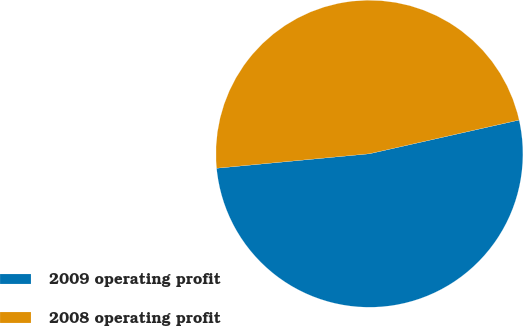Convert chart to OTSL. <chart><loc_0><loc_0><loc_500><loc_500><pie_chart><fcel>2009 operating profit<fcel>2008 operating profit<nl><fcel>52.02%<fcel>47.98%<nl></chart> 